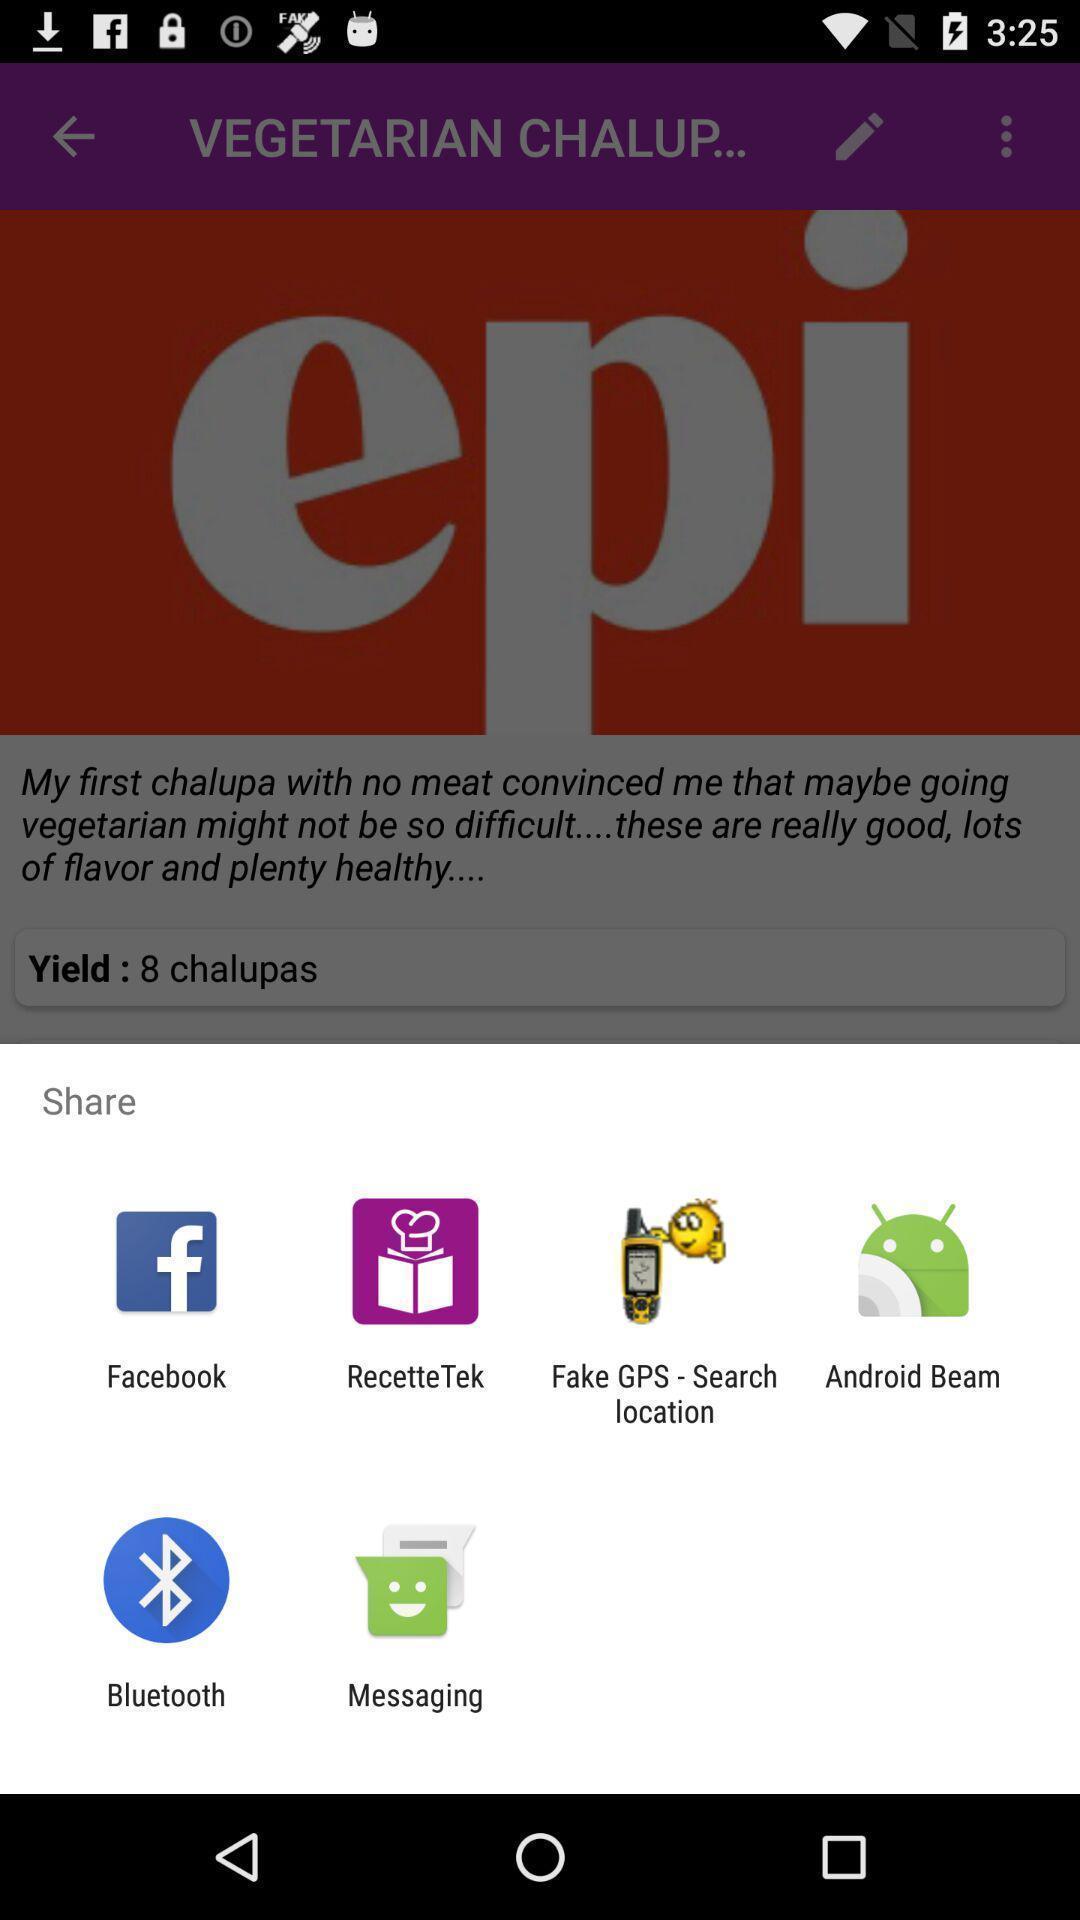Provide a textual representation of this image. Pop up showing various apps. 